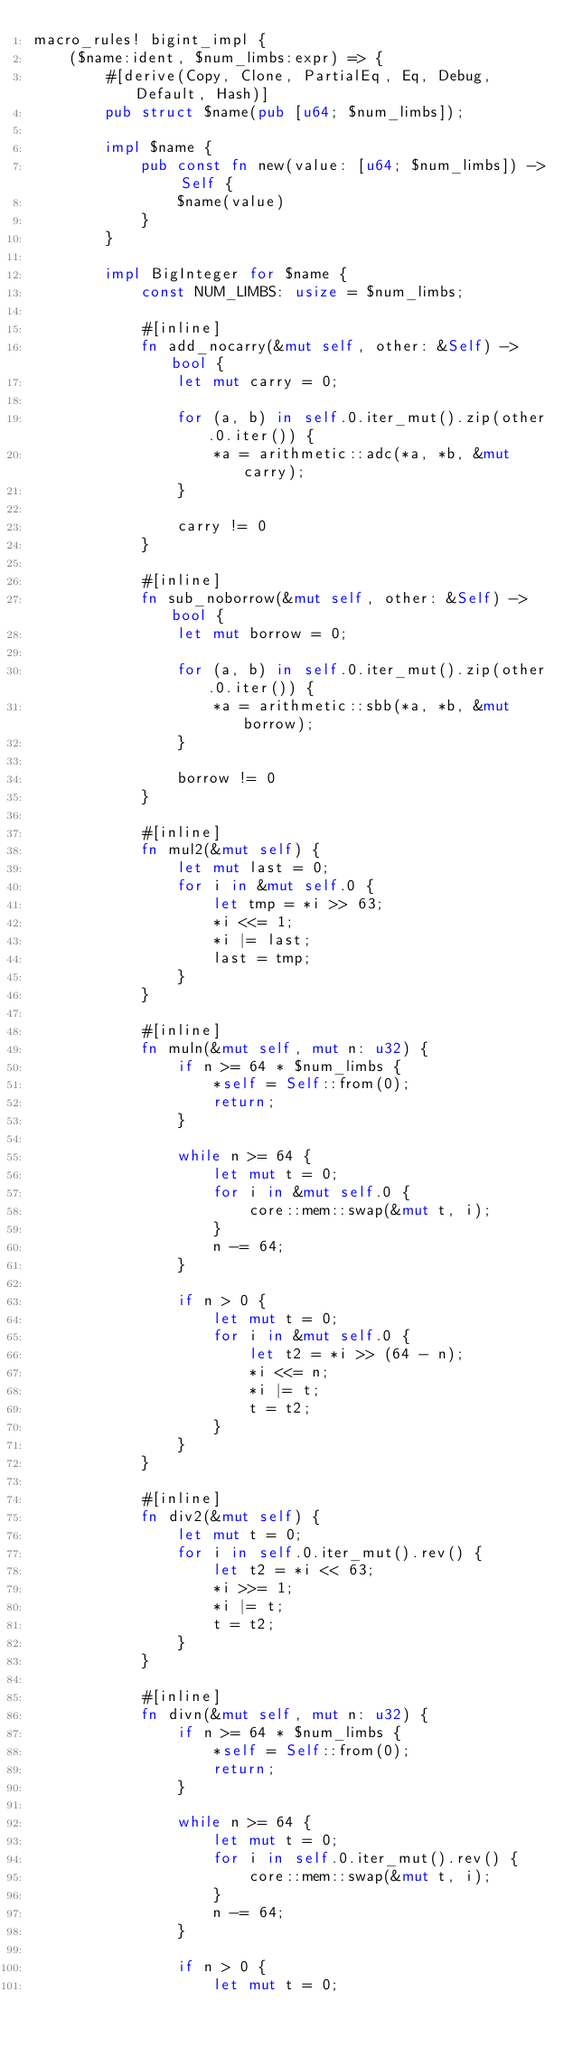Convert code to text. <code><loc_0><loc_0><loc_500><loc_500><_Rust_>macro_rules! bigint_impl {
    ($name:ident, $num_limbs:expr) => {
        #[derive(Copy, Clone, PartialEq, Eq, Debug, Default, Hash)]
        pub struct $name(pub [u64; $num_limbs]);

        impl $name {
            pub const fn new(value: [u64; $num_limbs]) -> Self {
                $name(value)
            }
        }

        impl BigInteger for $name {
            const NUM_LIMBS: usize = $num_limbs;

            #[inline]
            fn add_nocarry(&mut self, other: &Self) -> bool {
                let mut carry = 0;

                for (a, b) in self.0.iter_mut().zip(other.0.iter()) {
                    *a = arithmetic::adc(*a, *b, &mut carry);
                }

                carry != 0
            }

            #[inline]
            fn sub_noborrow(&mut self, other: &Self) -> bool {
                let mut borrow = 0;

                for (a, b) in self.0.iter_mut().zip(other.0.iter()) {
                    *a = arithmetic::sbb(*a, *b, &mut borrow);
                }

                borrow != 0
            }

            #[inline]
            fn mul2(&mut self) {
                let mut last = 0;
                for i in &mut self.0 {
                    let tmp = *i >> 63;
                    *i <<= 1;
                    *i |= last;
                    last = tmp;
                }
            }

            #[inline]
            fn muln(&mut self, mut n: u32) {
                if n >= 64 * $num_limbs {
                    *self = Self::from(0);
                    return;
                }

                while n >= 64 {
                    let mut t = 0;
                    for i in &mut self.0 {
                        core::mem::swap(&mut t, i);
                    }
                    n -= 64;
                }

                if n > 0 {
                    let mut t = 0;
                    for i in &mut self.0 {
                        let t2 = *i >> (64 - n);
                        *i <<= n;
                        *i |= t;
                        t = t2;
                    }
                }
            }

            #[inline]
            fn div2(&mut self) {
                let mut t = 0;
                for i in self.0.iter_mut().rev() {
                    let t2 = *i << 63;
                    *i >>= 1;
                    *i |= t;
                    t = t2;
                }
            }

            #[inline]
            fn divn(&mut self, mut n: u32) {
                if n >= 64 * $num_limbs {
                    *self = Self::from(0);
                    return;
                }

                while n >= 64 {
                    let mut t = 0;
                    for i in self.0.iter_mut().rev() {
                        core::mem::swap(&mut t, i);
                    }
                    n -= 64;
                }

                if n > 0 {
                    let mut t = 0;</code> 